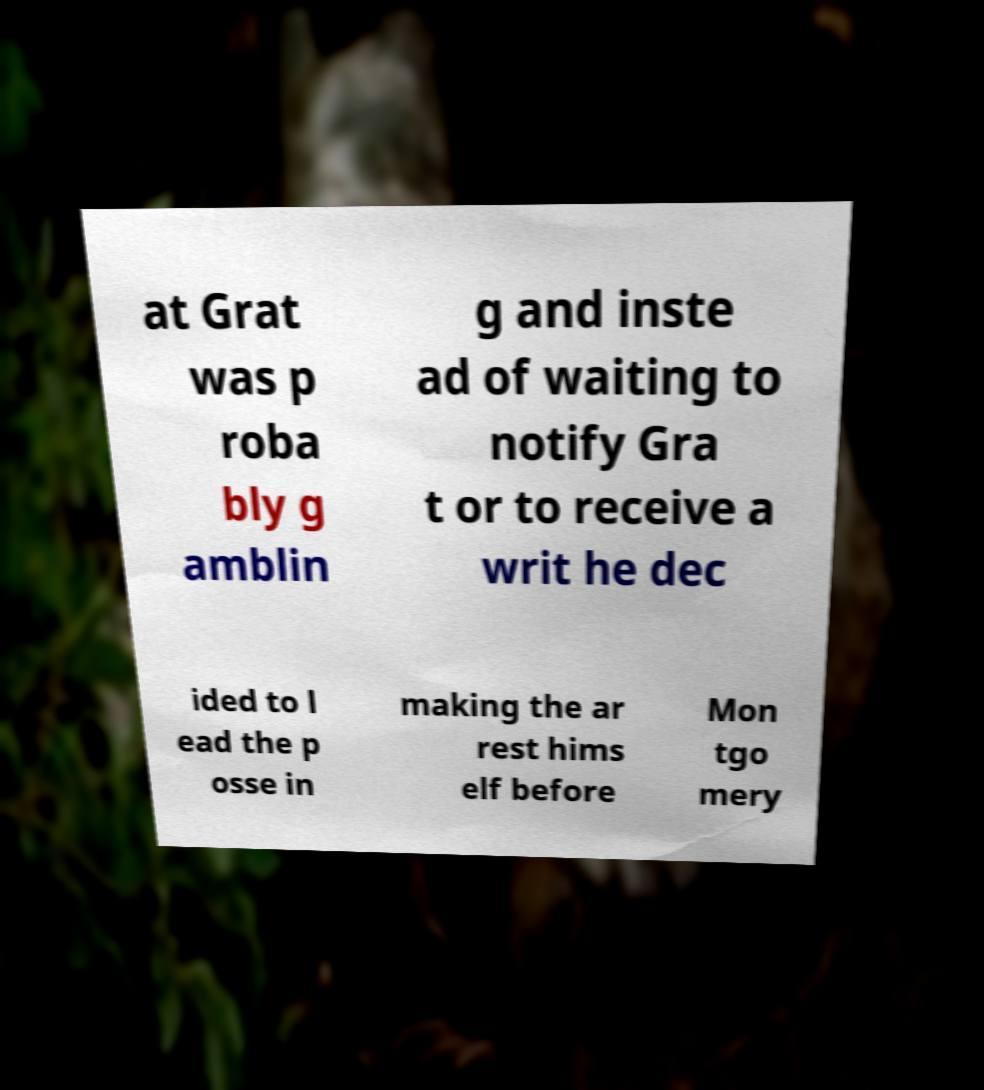What messages or text are displayed in this image? I need them in a readable, typed format. at Grat was p roba bly g amblin g and inste ad of waiting to notify Gra t or to receive a writ he dec ided to l ead the p osse in making the ar rest hims elf before Mon tgo mery 